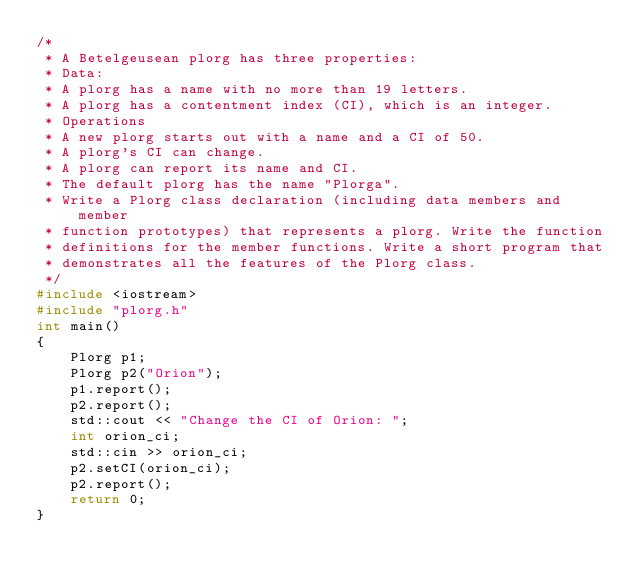Convert code to text. <code><loc_0><loc_0><loc_500><loc_500><_C++_>/*
 * A Betelgeusean plorg has three properties:
 * Data:
 * A plorg has a name with no more than 19 letters.
 * A plorg has a contentment index (CI), which is an integer.
 * Operations
 * A new plorg starts out with a name and a CI of 50.
 * A plorg's CI can change.
 * A plorg can report its name and CI.
 * The default plorg has the name "Plorga".
 * Write a Plorg class declaration (including data members and member
 * function prototypes) that represents a plorg. Write the function
 * definitions for the member functions. Write a short program that
 * demonstrates all the features of the Plorg class.
 */
#include <iostream>
#include "plorg.h"
int main()
{
    Plorg p1;
    Plorg p2("Orion");
    p1.report();
    p2.report();
    std::cout << "Change the CI of Orion: ";
    int orion_ci;
    std::cin >> orion_ci;
    p2.setCI(orion_ci);
    p2.report();
    return 0;
}
</code> 